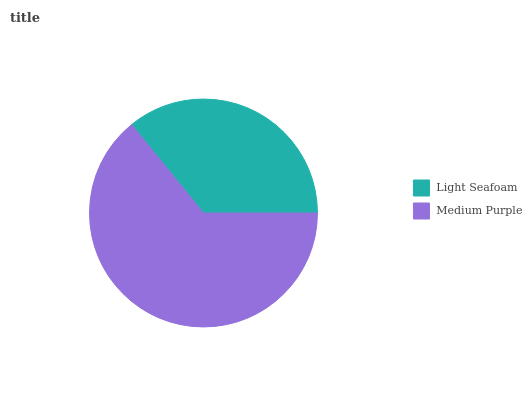Is Light Seafoam the minimum?
Answer yes or no. Yes. Is Medium Purple the maximum?
Answer yes or no. Yes. Is Medium Purple the minimum?
Answer yes or no. No. Is Medium Purple greater than Light Seafoam?
Answer yes or no. Yes. Is Light Seafoam less than Medium Purple?
Answer yes or no. Yes. Is Light Seafoam greater than Medium Purple?
Answer yes or no. No. Is Medium Purple less than Light Seafoam?
Answer yes or no. No. Is Medium Purple the high median?
Answer yes or no. Yes. Is Light Seafoam the low median?
Answer yes or no. Yes. Is Light Seafoam the high median?
Answer yes or no. No. Is Medium Purple the low median?
Answer yes or no. No. 